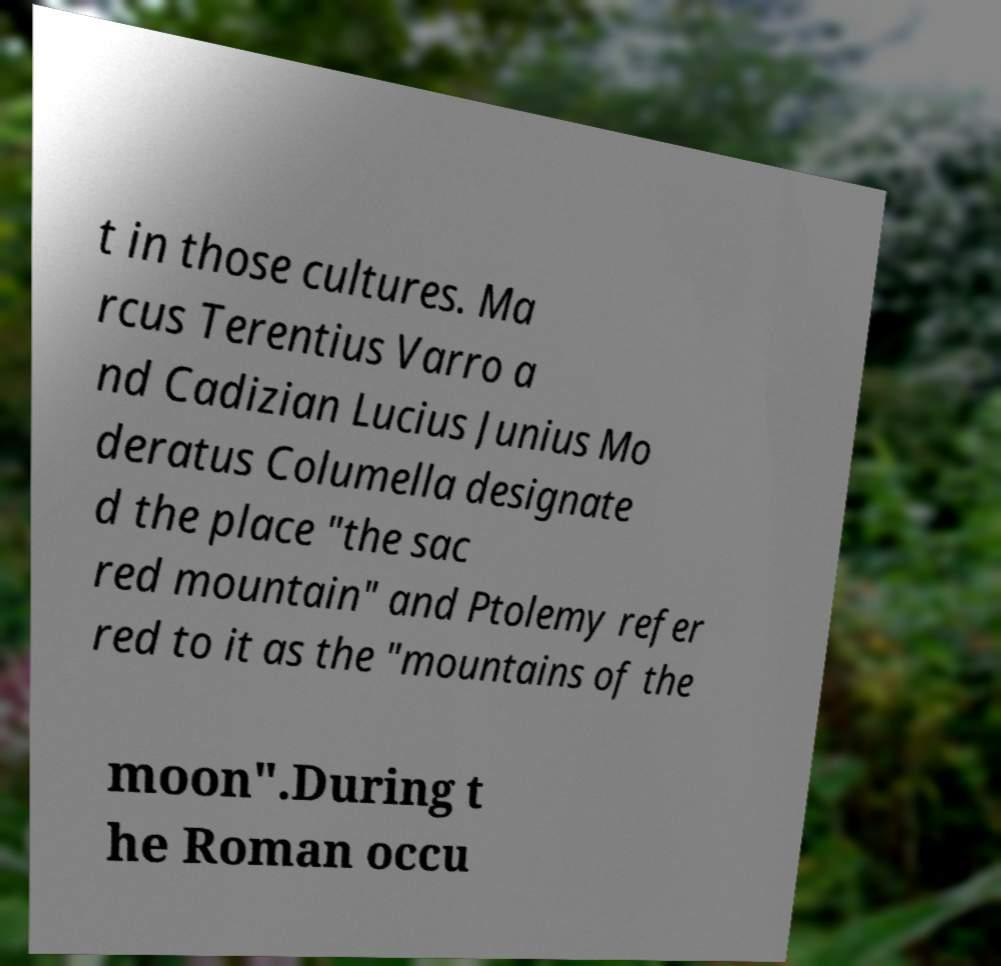Could you assist in decoding the text presented in this image and type it out clearly? t in those cultures. Ma rcus Terentius Varro a nd Cadizian Lucius Junius Mo deratus Columella designate d the place "the sac red mountain" and Ptolemy refer red to it as the "mountains of the moon".During t he Roman occu 